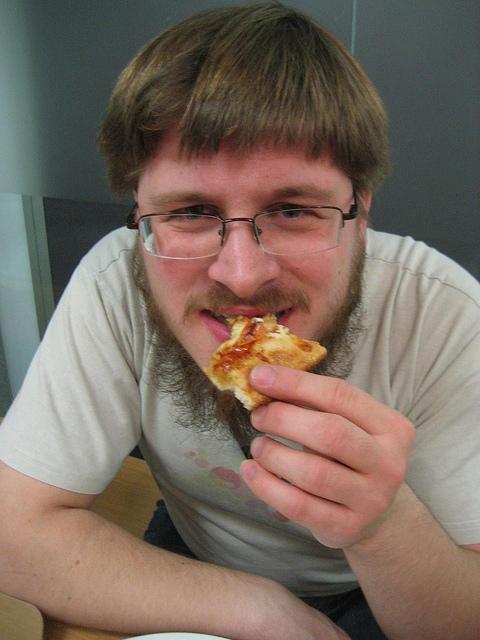Which hand holds the next bite?
Keep it brief. Left. Did this man shave recently?
Answer briefly. No. Is the man's shirt striped?
Be succinct. No. Is her sandwich vegetarian?
Quick response, please. No. Does this man have a beard?
Quick response, please. Yes. Is this man's shirt clean?
Give a very brief answer. No. Does the man have any tattoos?
Give a very brief answer. No. What is the man eating?
Write a very short answer. Pizza. 